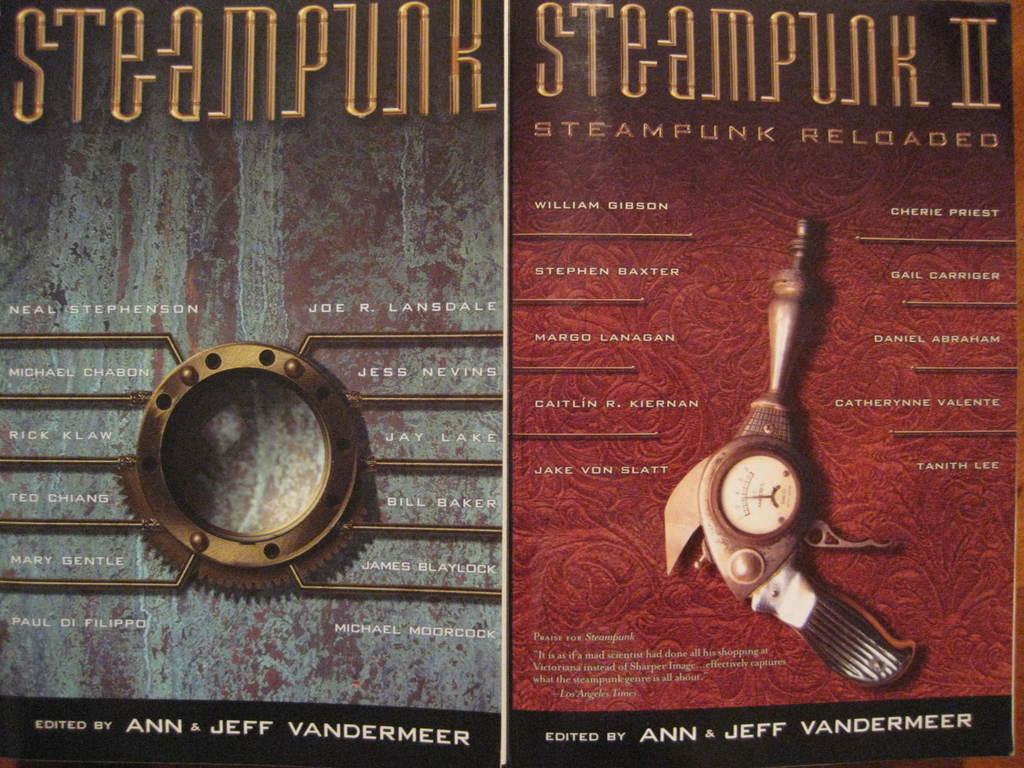Describe this image in one or two sentences. In this image we can see posters with text and images of some objects. 